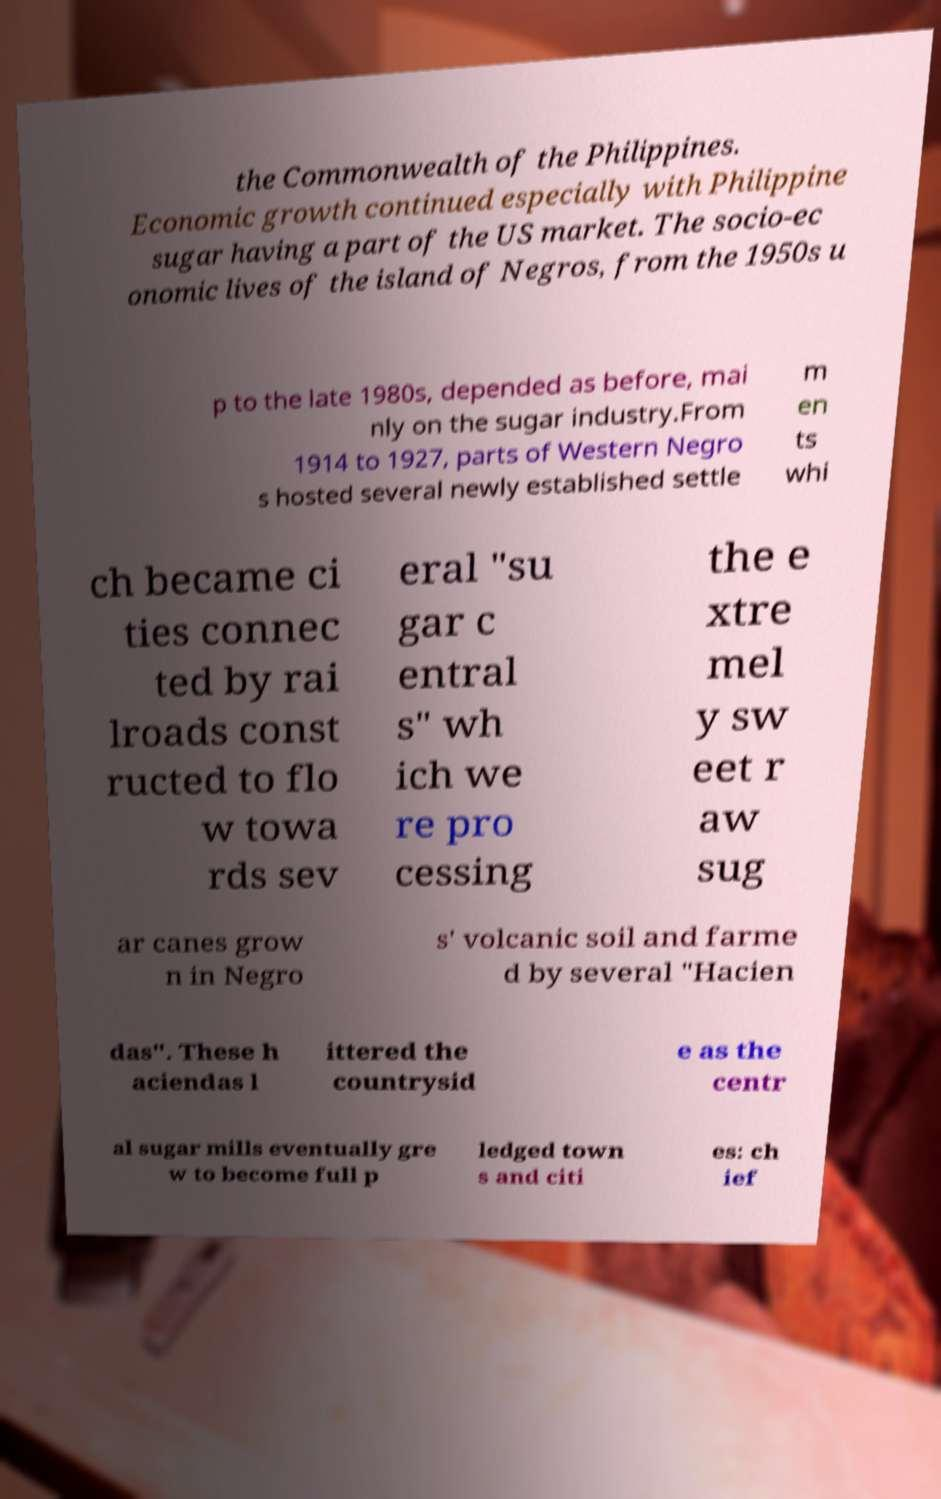Could you assist in decoding the text presented in this image and type it out clearly? the Commonwealth of the Philippines. Economic growth continued especially with Philippine sugar having a part of the US market. The socio-ec onomic lives of the island of Negros, from the 1950s u p to the late 1980s, depended as before, mai nly on the sugar industry.From 1914 to 1927, parts of Western Negro s hosted several newly established settle m en ts whi ch became ci ties connec ted by rai lroads const ructed to flo w towa rds sev eral "su gar c entral s" wh ich we re pro cessing the e xtre mel y sw eet r aw sug ar canes grow n in Negro s' volcanic soil and farme d by several "Hacien das". These h aciendas l ittered the countrysid e as the centr al sugar mills eventually gre w to become full p ledged town s and citi es: ch ief 